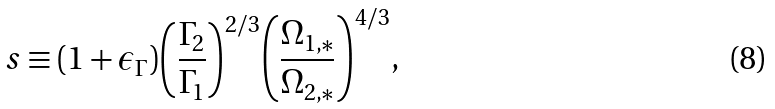Convert formula to latex. <formula><loc_0><loc_0><loc_500><loc_500>s \equiv ( 1 + \epsilon _ { \Gamma } ) { \left ( \frac { \Gamma _ { 2 } } { \Gamma _ { 1 } } \right ) } ^ { 2 / 3 } { \left ( \frac { \Omega _ { 1 , * } } { \Omega _ { 2 , * } } \right ) } ^ { 4 / 3 } ,</formula> 